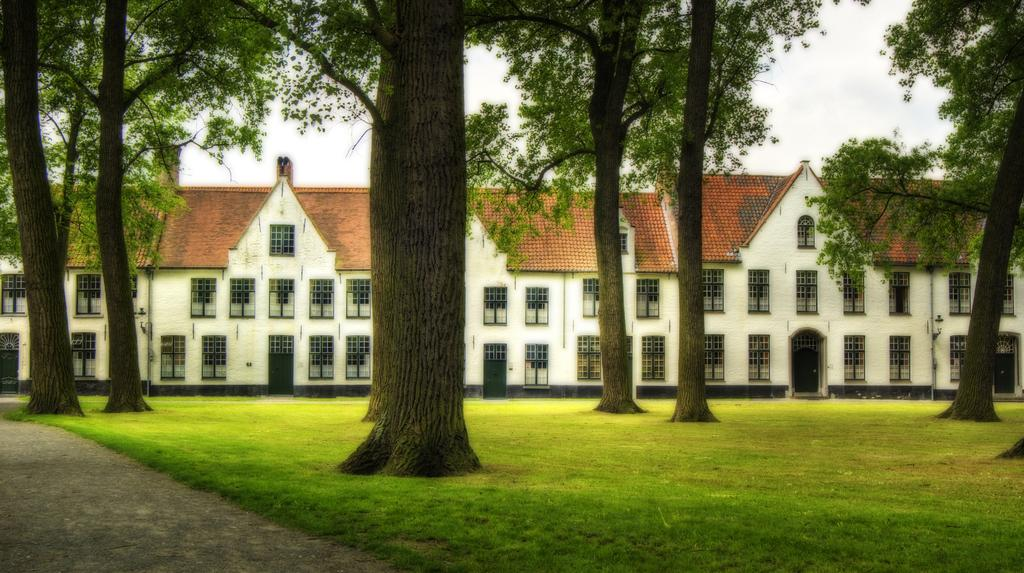What type of vegetation can be seen in the image? There are trees and grass in the image. What kind of path is present in the image? There is a walkway in the image. What type of structure is visible in the image? There is a house in the image. What are the main features of the house? The house has walls, doors, and windows. What can be seen in the background of the image? The sky is visible in the background of the image. Reasoning: Let'ing: Let's think step by step in order to produce the conversation. We start by identifying the main subjects and objects in the image based on the provided facts. We then formulate questions that focus on the location and characteristics of these subjects and objects, ensuring that each question can be answered definitively with the information given. We avoid yes/no questions and ensure that the language is simple and clear. Absurd Question/Answer: What type of lamp is hanging from the flesh in the image? There is no lamp or flesh present in the image. How does the house twist in the image? The house does not twist in the image; it is a stationary structure with walls, doors, and windows. How does the house twist in the image? The house does not twist in the image; it is a stationary structure with walls, doors, and windows. 